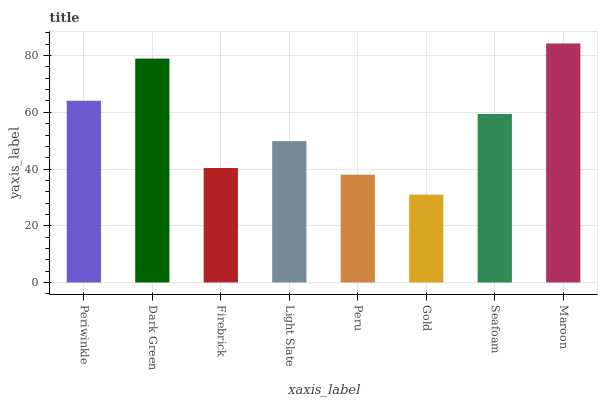Is Gold the minimum?
Answer yes or no. Yes. Is Maroon the maximum?
Answer yes or no. Yes. Is Dark Green the minimum?
Answer yes or no. No. Is Dark Green the maximum?
Answer yes or no. No. Is Dark Green greater than Periwinkle?
Answer yes or no. Yes. Is Periwinkle less than Dark Green?
Answer yes or no. Yes. Is Periwinkle greater than Dark Green?
Answer yes or no. No. Is Dark Green less than Periwinkle?
Answer yes or no. No. Is Seafoam the high median?
Answer yes or no. Yes. Is Light Slate the low median?
Answer yes or no. Yes. Is Maroon the high median?
Answer yes or no. No. Is Dark Green the low median?
Answer yes or no. No. 